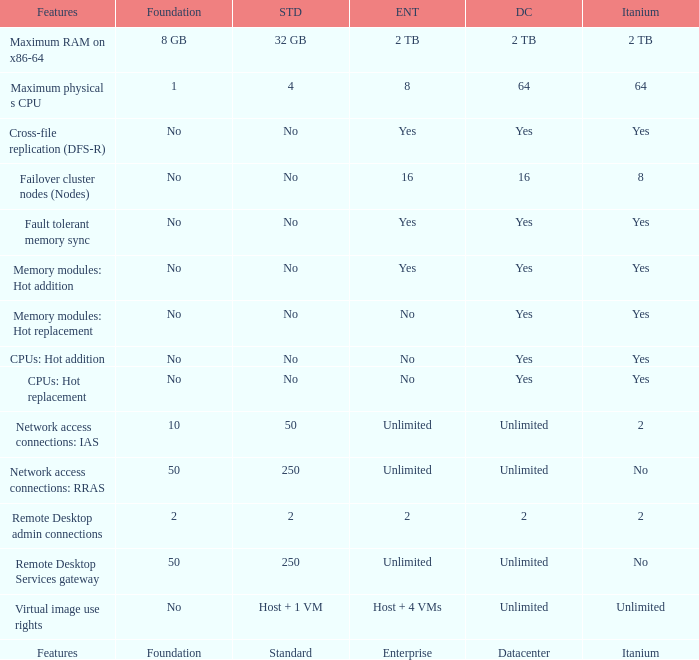What Datacenter is listed against the network access connections: rras Feature? Unlimited. 